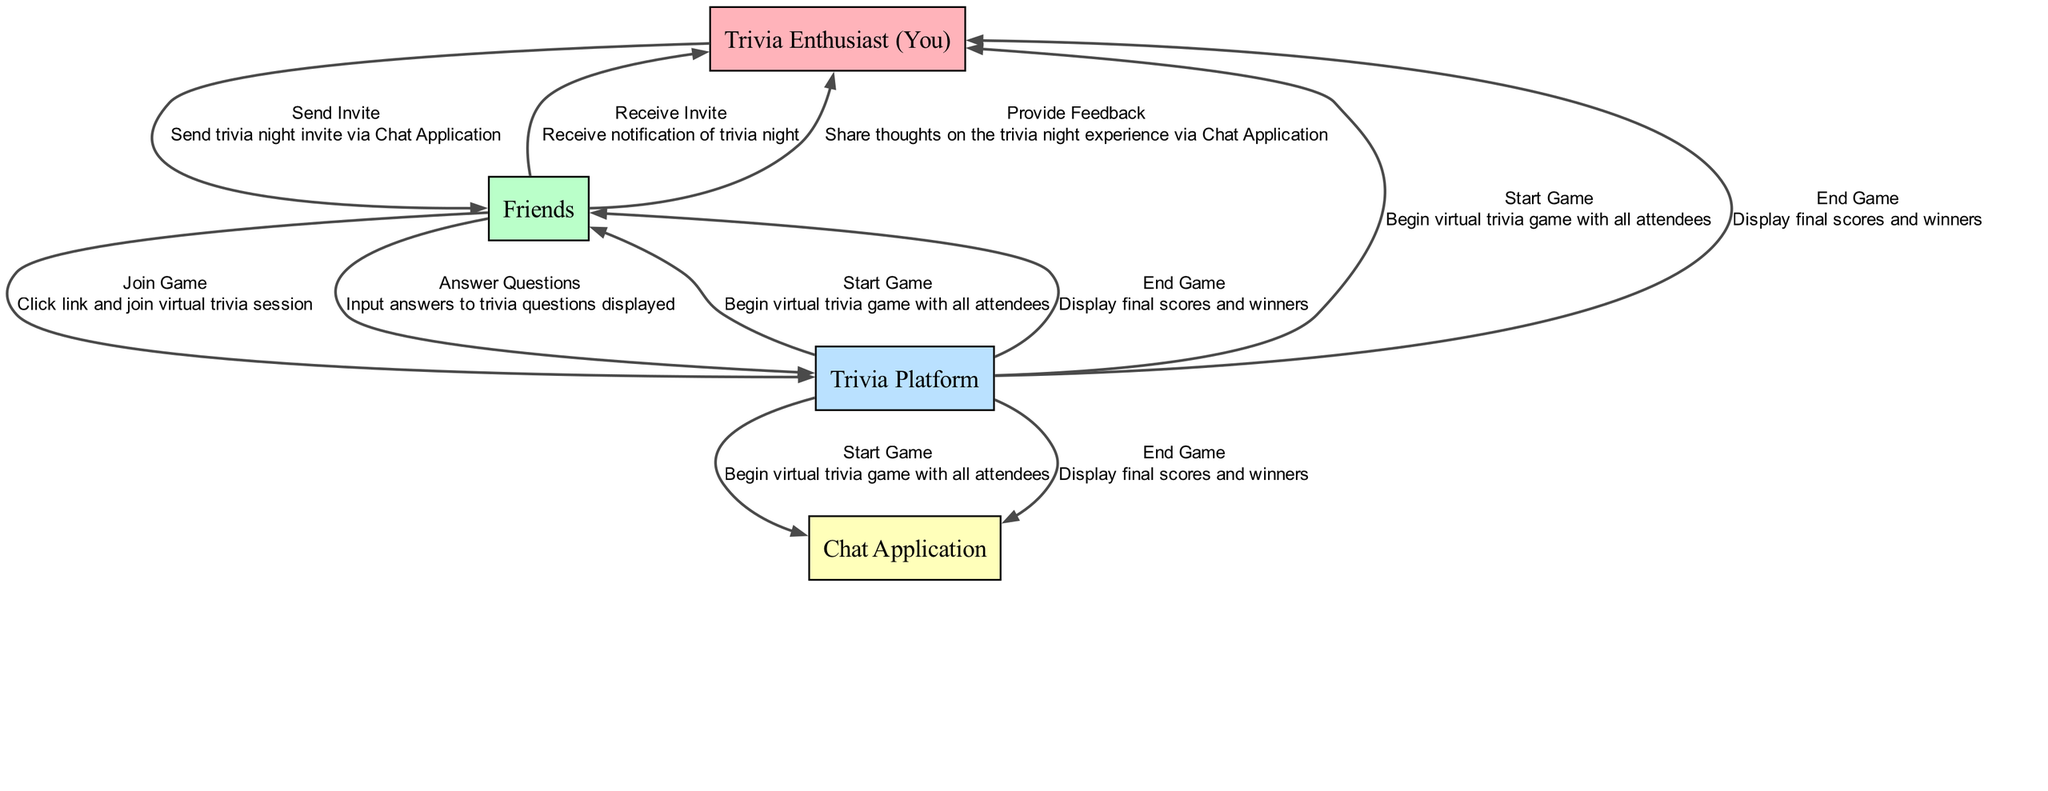What action does the Trivia Enthusiast (You) perform first? The first action in the sequence diagram is "Send Invite" from the Trivia Enthusiast (You) to Friends.
Answer: Send Invite How many participants are involved in this virtual trivia night? The diagram lists four participants: Trivia Enthusiast (You), Friends, Trivia Platform, and Chat Application. Therefore, there are four participants.
Answer: Four What is the last action taken in the sequence? The last action mentioned in the sequence diagram is "Provide Feedback" from Friends to the Trivia Enthusiast (You).
Answer: Provide Feedback Which participant receives the trivia night invitation? In the diagram, the Friends are the ones who receive the trivia night invitation sent by the Trivia Enthusiast (You).
Answer: Friends How many actions are performed between the Trivia Enthusiast (You) and Friends? There are three actions involving both the Trivia Enthusiast (You) and Friends: "Send Invite," "Receive Invite," and "Provide Feedback."
Answer: Three What is the primary platform used for the trivia game? The Trivia Platform is identified as the primary platform used for the virtual trivia game within the diagram.
Answer: Trivia Platform Which action occurs immediately after Friends join the game? After Friends join the game by clicking the link, the next action that occurs is "Start Game" which is initiated by the Trivia Platform.
Answer: Start Game What do Friends do to interact with the trivia questions? Friends input answers to trivia questions displayed during the game, as indicated in the diagram.
Answer: Input answers to trivia questions What happens at the end of the trivia night? The end of the trivia night includes the action "End Game," where the Trivia Platform displays final scores and winners to all participants.
Answer: End Game Which communication method is used for sending the invite? The Trivia Enthusiast (You) sends the trivia night invite via a Chat Application, as shown in the sequence.
Answer: Chat Application 